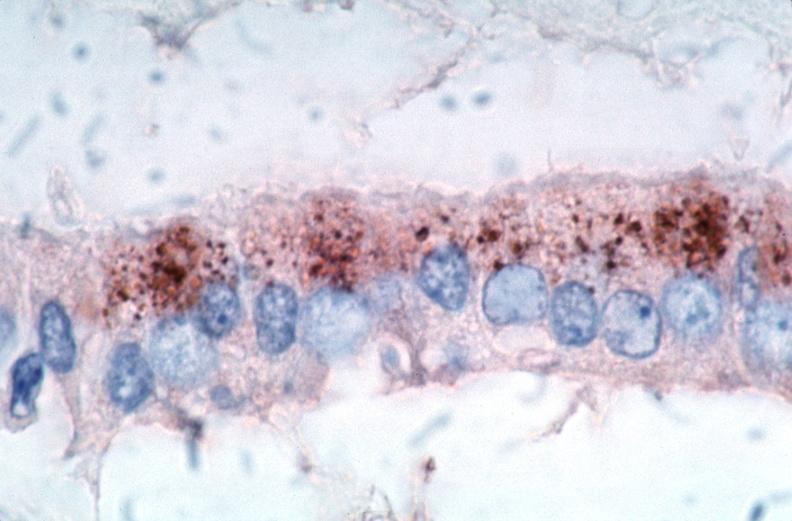what does this image show?
Answer the question using a single word or phrase. Vasculitis 